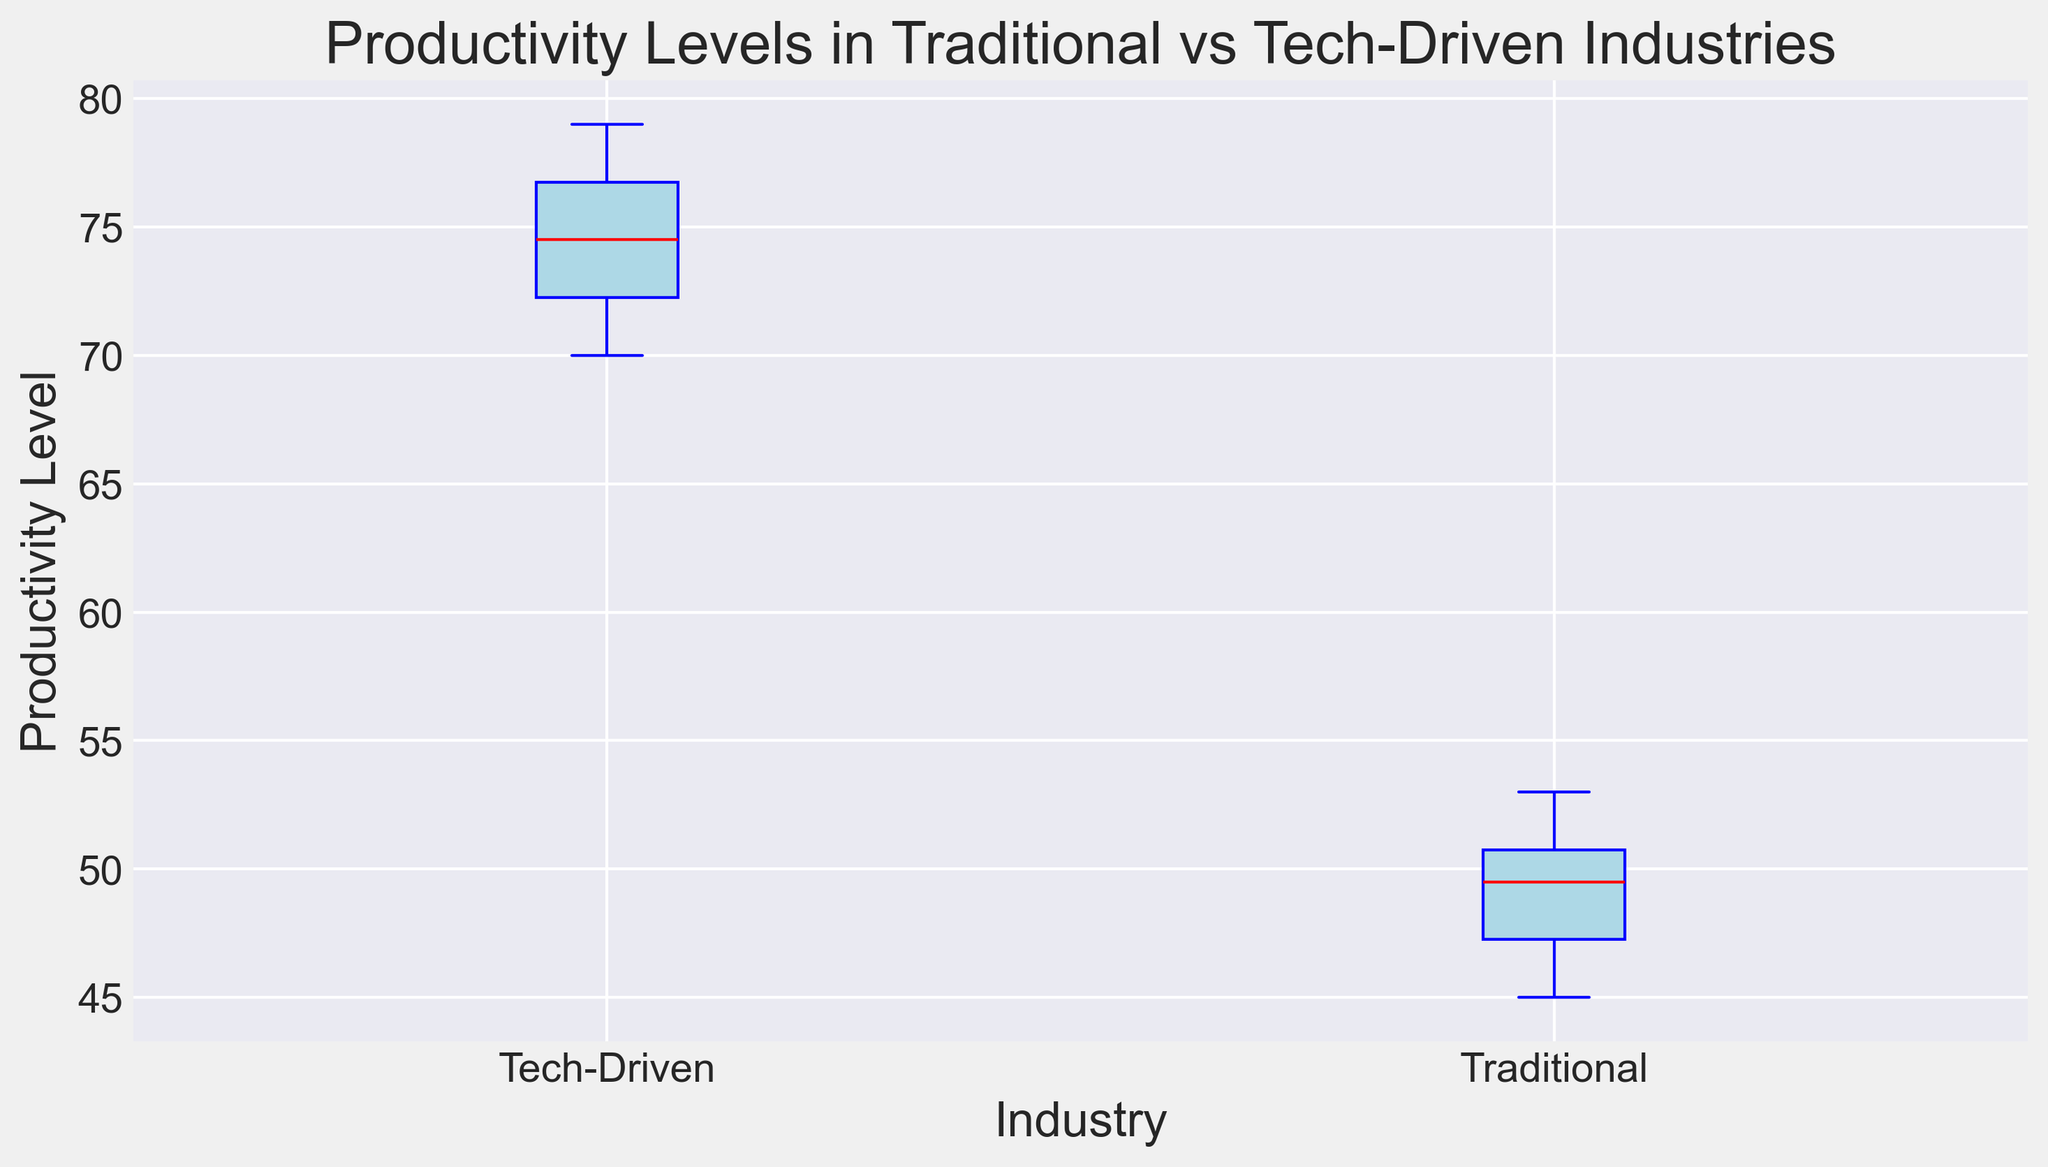What is the median productivity level for traditional industries? To find the median productivity level for traditional industries, look at the box plot for the traditional industries. The median is shown as the red line inside the box.
Answer: 50 Which industry has a higher variation in productivity levels? Look at the length of the boxes and the whiskers representing the range of productivity levels for both traditional and tech-driven industries. The box and whiskers for tech-driven industries are longer, indicating higher variation.
Answer: Tech-Driven What are the interquartile ranges (IQR) for both traditional and tech-driven industries? The IQR is the length of the box between the 25th and 75th percentiles. For traditional industries, the IQR is from 47 to 51. For tech-driven, it is from 71 to 76. Calculate the difference for both: Traditional IQR = 51 - 47 = 4; Tech-Driven IQR = 76 - 71 = 5.
Answer: Traditional: 4, Tech-Driven: 5 Which industry shows a higher median productivity level? Compare the median lines (red) in the boxes of both industries. The median for tech-driven industries is higher than that of traditional industries.
Answer: Tech-Driven How do the maximum productivity levels compare between traditional and tech-driven industries? Observe the top whiskers that indicate the maximum values. The tech-driven industry's top whisker is higher, indicating a higher maximum productivity level.
Answer: Tech-Driven What is the difference between the median productivity levels of traditional and tech-driven industries? The median productivity level for traditional industries is 50, and for tech-driven industries, it's about 73. Calculate the difference: 73 - 50 = 23.
Answer: 23 Which industry presents more outliers? Look for the green dots outside the whiskers, which represent outliers. There are more green dots for the tech-driven industries, indicating more outliers.
Answer: Tech-Driven What is the lower quartile (Q1) productivity level for traditional industries? The lower quartile (Q1) is the bottom edge of the box for traditional industries. It is around 47.
Answer: 47 What is the range of productivity levels in tech-driven industries? The range is the difference between the maximum and minimum values indicated by the whiskers. The max value appears to be 79 and the minimum is 70. Calculate the range: 79 - 70 = 9.
Answer: 9 Compare the range of productivity levels between traditional and tech-driven industries. The range for traditional industries is the difference between the max (53) and min (45) values: 53 - 45 = 8. For tech-driven, it's 79 - 70 = 9. Hence, tech-driven has a slightly larger range.
Answer: Tech-Driven 